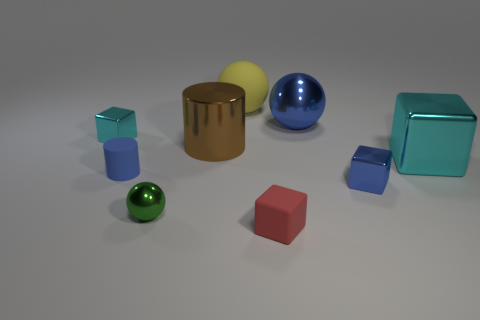Add 1 big cylinders. How many objects exist? 10 Subtract all green cubes. Subtract all green spheres. How many cubes are left? 4 Subtract all blocks. How many objects are left? 5 Add 6 large yellow matte things. How many large yellow matte things are left? 7 Add 5 green metal spheres. How many green metal spheres exist? 6 Subtract 1 blue balls. How many objects are left? 8 Subtract all blue shiny spheres. Subtract all metallic spheres. How many objects are left? 6 